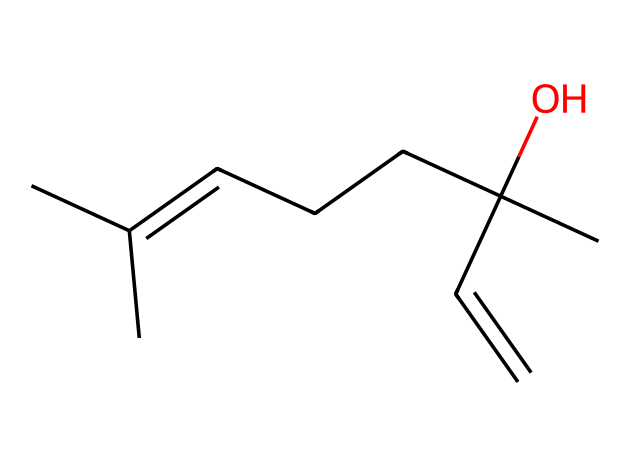how many carbon atoms are in linalool? In the provided SMILES representation, count the 'C' symbols to determine the number of carbon atoms. There are ten 'C' symbols present in the structure.
Answer: ten how many hydroxyl groups does linalool contain? A hydroxyl group is represented as '-OH' in chemical structures. In the SMILES, there is one 'O' connected to a hydrogen (inferred from the OH structure), indicating one hydroxyl group.
Answer: one what type of functional group is present in linalool? The presence of a hydroxyl group (-OH) indicates that linalool contains an alcohol functional group, which is characteristic of terpenes with relaxing properties.
Answer: alcohol is linalool a cyclic or acyclic compound? An acyclic compound contains a linear structure without rings. The SMILES representation does not show any cyclic components; hence, linalool is acyclic.
Answer: acyclic does linalool have any double bonds? The 'C=C' part of the SMILES indicates the presence of a double bond between two carbon atoms, which affects its reactivity and aromatic properties.
Answer: yes what is the molecular weight of linalool? An estimate of molecular weight can be calculated based on the atoms present (10 carbons, 18 hydrogens, 1 oxygen). The total comes out to approximately 154.25 g/mol.
Answer: 154.25 what category of terpenes does linalool belong to? Linalool is classified as a monoterpene due to its structure, which consists of 10 carbon atoms arranged in a specific way, typical of monoterpenes.
Answer: monoterpene 